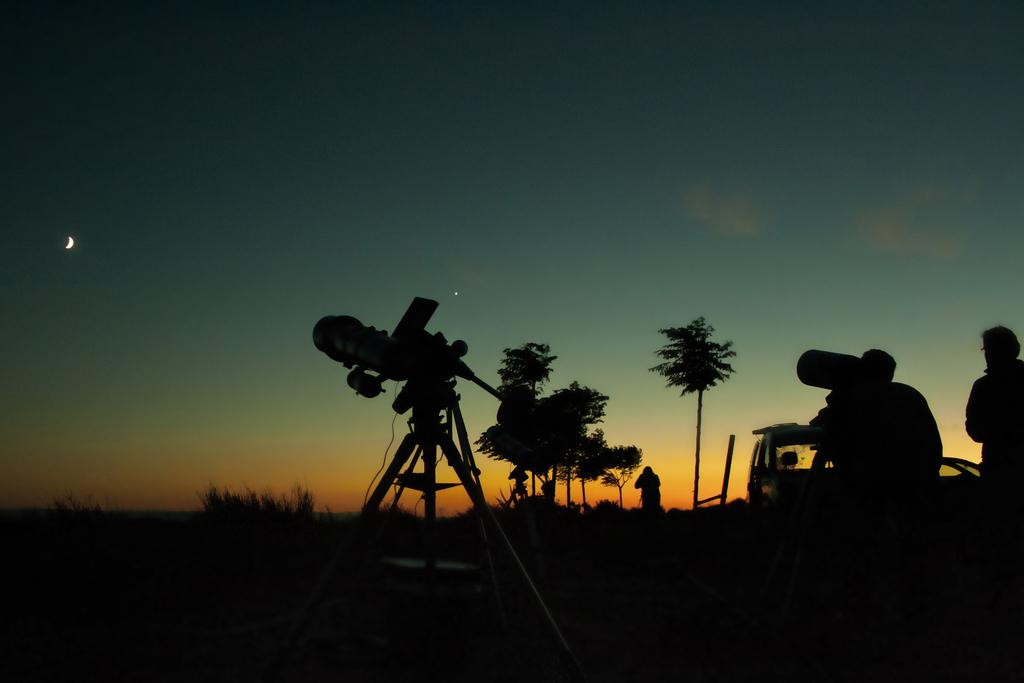How many people are in the image? There are three persons in the image. What can be seen in the background of the image? The sky is visible in the background of the image. What type of object is present in the image that people might use to display or sell items? There is a stand in the image that could be used for this purpose. What else is present in the image besides the people and the stand? There are trees, a vehicle, and a device in the image. What type of weather condition is the mother discussing with the other persons in the image? There is no mention of a mother or any discussion about the weather in the image. 